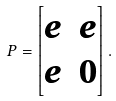Convert formula to latex. <formula><loc_0><loc_0><loc_500><loc_500>P = \begin{bmatrix} e & e \\ e & 0 \end{bmatrix} .</formula> 